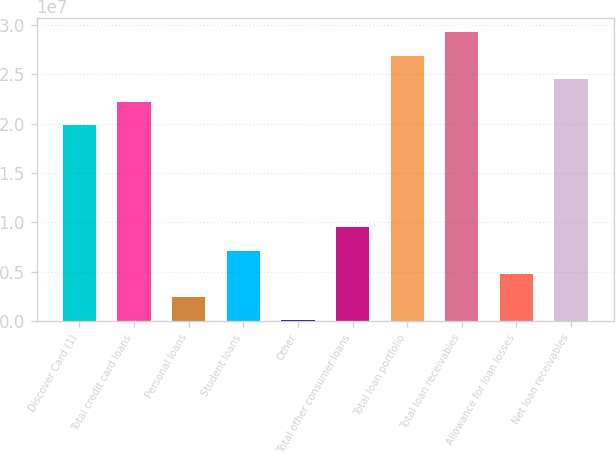Convert chart. <chart><loc_0><loc_0><loc_500><loc_500><bar_chart><fcel>Discover Card (1)<fcel>Total credit card loans<fcel>Personal loans<fcel>Student loans<fcel>Other<fcel>Total other consumer loans<fcel>Total loan portfolio<fcel>Total loan receivables<fcel>Allowance for loan losses<fcel>Net loan receivables<nl><fcel>1.98262e+07<fcel>2.21818e+07<fcel>2.42383e+06<fcel>7.13522e+06<fcel>68137<fcel>9.49092e+06<fcel>2.68932e+07<fcel>2.92489e+07<fcel>4.77953e+06<fcel>2.45375e+07<nl></chart> 